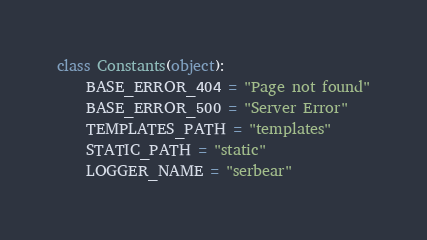Convert code to text. <code><loc_0><loc_0><loc_500><loc_500><_Python_>class Constants(object):
    BASE_ERROR_404 = "Page not found"
    BASE_ERROR_500 = "Server Error"
    TEMPLATES_PATH = "templates"
    STATIC_PATH = "static"
    LOGGER_NAME = "serbear"
</code> 